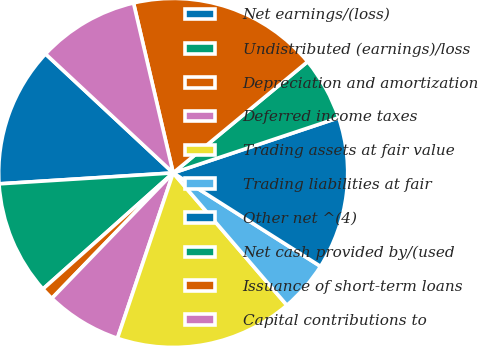Convert chart. <chart><loc_0><loc_0><loc_500><loc_500><pie_chart><fcel>Net earnings/(loss)<fcel>Undistributed (earnings)/loss<fcel>Depreciation and amortization<fcel>Deferred income taxes<fcel>Trading assets at fair value<fcel>Trading liabilities at fair<fcel>Other net ^(4)<fcel>Net cash provided by/(used<fcel>Issuance of short-term loans<fcel>Capital contributions to<nl><fcel>12.94%<fcel>10.59%<fcel>1.18%<fcel>7.06%<fcel>16.47%<fcel>4.71%<fcel>14.12%<fcel>5.88%<fcel>17.65%<fcel>9.41%<nl></chart> 